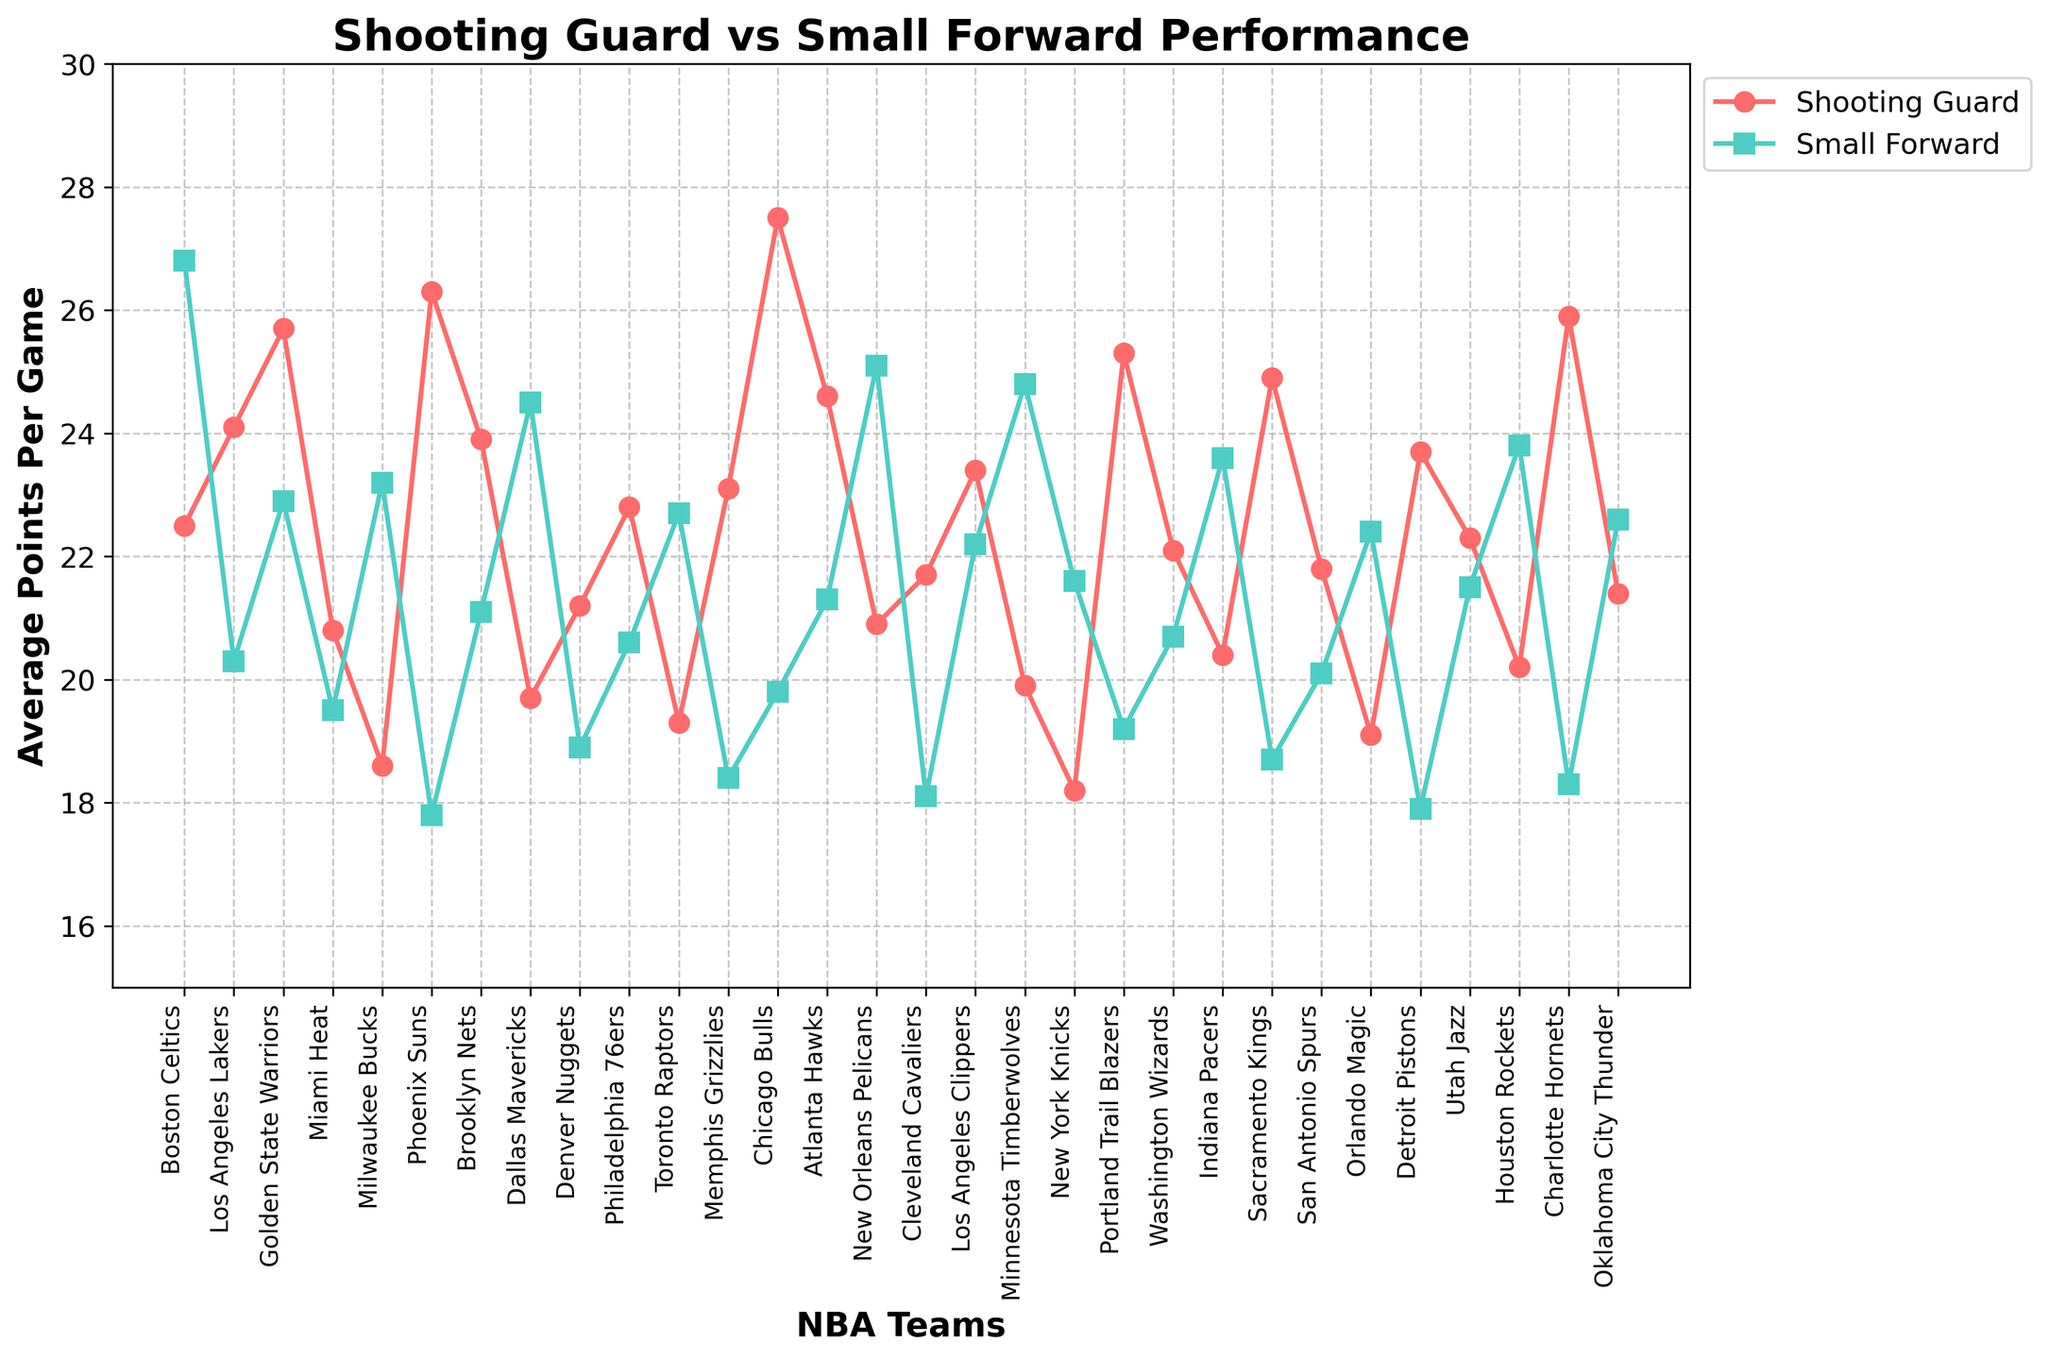Which team has a higher average points per game for Shooting Guards compared to Small Forwards? To find the answer, compare the values for Shooting Guard PPG and Small Forward PPG for each team. The teams with higher values for Shooting Guards include Boston Celtics, Los Angeles Lakers, Golden State Warriors, Miami Heat, Phoenix Suns, Brooklyn Nets, Philadelphia 76ers, Memphis Grizzlies, Chicago Bulls, Atlanta Hawks, Cleveland Cavaliers, Los Angeles Clippers, Sacramento Kings, San Antonio Spurs, Detroit Pistons, and Charlotte Hornets.
Answer: 16 teams Which team has the smallest difference in average points per game between Shooting Guards and Small Forwards? Calculate the absolute difference for each team by subtracting the smaller PPG from the larger PPG. The smallest difference is for the Los Angeles Clippers, with a difference of 1.2 points.
Answer: Los Angeles Clippers What is the overall average points per game for Small Forwards across all teams? To get the overall average, sum all the Small Forward PPG values and divide by the number of teams. \( (26.8 + 20.3 + 22.9 + 19.5 + 23.2 + 17.8 + 21.1 + 24.5 + 18.9 + 20.6 + 22.7 + 18.4 + 19.8 + 21.3 + 25.1 + 18.1 + 22.2 + 24.8 + 21.6 + 19.2 + 20.7 + 23.6 + 18.7 + 20.1 + 22.4 + 17.9 + 21.5 + 23.8 + 18.3 + 22.6) \div 30 = 21.12 \)
Answer: 21.12 Which team's Shooting Guard has the highest average points per game? Scan through the values for Shooting Guard PPG and identify the highest value. The Chicago Bulls' Shooting Guard has the highest PPG at 27.5.
Answer: Chicago Bulls How much higher is the average points per game of the Boston Celtics' Small Forward compared to their Shooting Guard? Subtract the Shooting Guard PPG from the Small Forward PPG for the Boston Celtics. \( 26.8 - 22.5 = 4.3 \) points higher.
Answer: 4.3 Which teams have both Shooting Guards and Small Forwards scoring more than 20 PPG? Identify the teams where both the Shooting Guard PPG and Small Forward PPG are greater than 20: Boston Celtics, Los Angeles Lakers, Golden State Warriors, Brooklyn Nets, Philadelphia 76ers, Atlanta Hawks, Los Angeles Clippers, Utah Jazz, and Oklahoma City Thunder.
Answer: 9 teams In the plotted graph, which position (Shooting Guard or Small Forward) is represented with circles? Observing the plot, the circles are used to represent data points for Shooting Guards.
Answer: Shooting Guard What's the average difference in PPG between Shooting Guards and Small Forwards for all teams? Calculate the difference for each team, sum these differences, and divide by the number of teams. The overall differences are summed as follows: \( (4.3 + 3.8 + 2.8 + 1.3 + 4.6 + 8.5 + 2.8 + 4.8 + 2.3 + 2.2 + 3.4 + 4.7 + 7.7 + 3.3 + 4.2 + 3.6 + 1.2 + 4.9 + 3.4 + 6.1 + 1.4 + 3.2 + 6.2 + 1.7 + 3.3 + 5.8 + 0.8 + 3.6 + 7.6 + 1.2) \div 30 = 3.59 \)
Answer: 3.59 